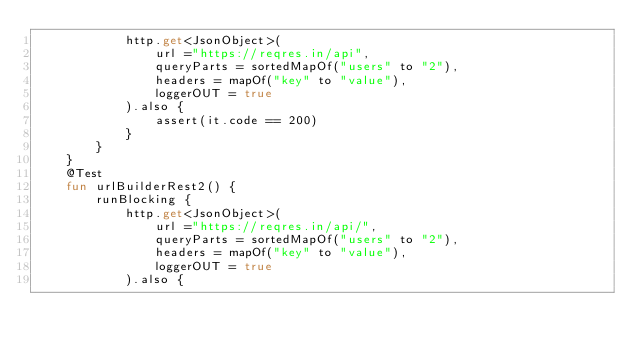<code> <loc_0><loc_0><loc_500><loc_500><_Kotlin_>            http.get<JsonObject>(
                url ="https://reqres.in/api",
                queryParts = sortedMapOf("users" to "2"),
                headers = mapOf("key" to "value"),
                loggerOUT = true
            ).also {
                assert(it.code == 200)
            }
        }
    }
    @Test
    fun urlBuilderRest2() {
        runBlocking {
            http.get<JsonObject>(
                url ="https://reqres.in/api/",
                queryParts = sortedMapOf("users" to "2"),
                headers = mapOf("key" to "value"),
                loggerOUT = true
            ).also {</code> 